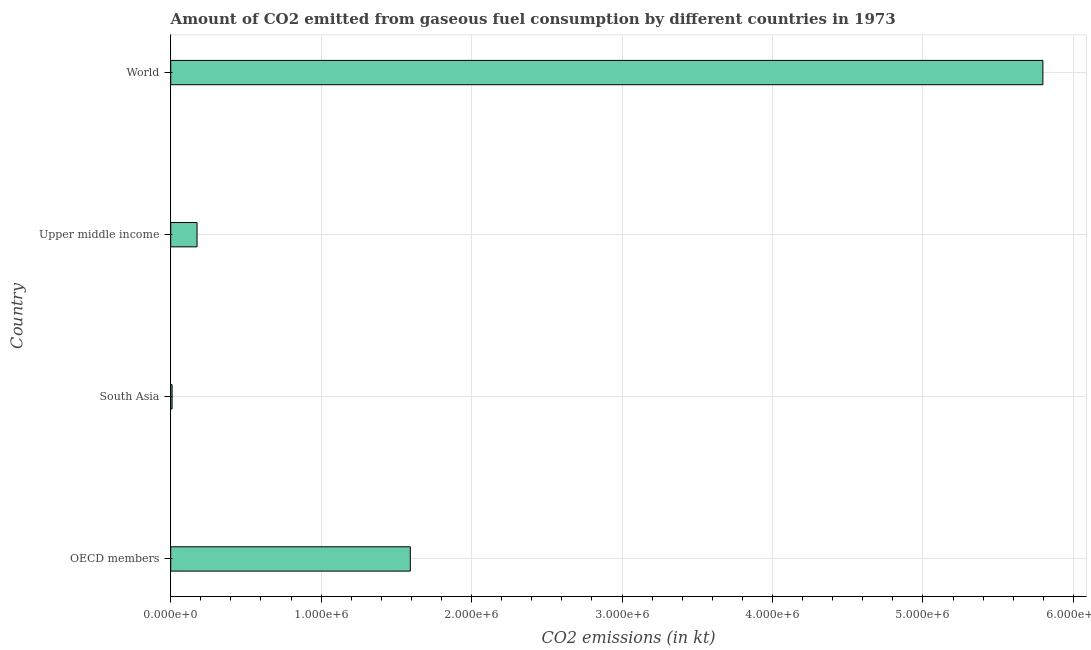Does the graph contain any zero values?
Make the answer very short. No. Does the graph contain grids?
Your response must be concise. Yes. What is the title of the graph?
Provide a short and direct response. Amount of CO2 emitted from gaseous fuel consumption by different countries in 1973. What is the label or title of the X-axis?
Give a very brief answer. CO2 emissions (in kt). What is the co2 emissions from gaseous fuel consumption in OECD members?
Provide a succinct answer. 1.59e+06. Across all countries, what is the maximum co2 emissions from gaseous fuel consumption?
Keep it short and to the point. 5.80e+06. Across all countries, what is the minimum co2 emissions from gaseous fuel consumption?
Ensure brevity in your answer.  9117.53. What is the sum of the co2 emissions from gaseous fuel consumption?
Make the answer very short. 7.57e+06. What is the difference between the co2 emissions from gaseous fuel consumption in South Asia and World?
Make the answer very short. -5.79e+06. What is the average co2 emissions from gaseous fuel consumption per country?
Your response must be concise. 1.89e+06. What is the median co2 emissions from gaseous fuel consumption?
Your response must be concise. 8.84e+05. What is the ratio of the co2 emissions from gaseous fuel consumption in OECD members to that in World?
Offer a very short reply. 0.28. Is the difference between the co2 emissions from gaseous fuel consumption in OECD members and World greater than the difference between any two countries?
Offer a terse response. No. What is the difference between the highest and the second highest co2 emissions from gaseous fuel consumption?
Keep it short and to the point. 4.20e+06. What is the difference between the highest and the lowest co2 emissions from gaseous fuel consumption?
Your answer should be compact. 5.79e+06. In how many countries, is the co2 emissions from gaseous fuel consumption greater than the average co2 emissions from gaseous fuel consumption taken over all countries?
Keep it short and to the point. 1. How many bars are there?
Keep it short and to the point. 4. Are all the bars in the graph horizontal?
Offer a terse response. Yes. What is the difference between two consecutive major ticks on the X-axis?
Give a very brief answer. 1.00e+06. What is the CO2 emissions (in kt) in OECD members?
Provide a short and direct response. 1.59e+06. What is the CO2 emissions (in kt) of South Asia?
Give a very brief answer. 9117.53. What is the CO2 emissions (in kt) in Upper middle income?
Offer a terse response. 1.75e+05. What is the CO2 emissions (in kt) of World?
Your answer should be compact. 5.80e+06. What is the difference between the CO2 emissions (in kt) in OECD members and South Asia?
Give a very brief answer. 1.58e+06. What is the difference between the CO2 emissions (in kt) in OECD members and Upper middle income?
Provide a succinct answer. 1.42e+06. What is the difference between the CO2 emissions (in kt) in OECD members and World?
Provide a succinct answer. -4.20e+06. What is the difference between the CO2 emissions (in kt) in South Asia and Upper middle income?
Keep it short and to the point. -1.66e+05. What is the difference between the CO2 emissions (in kt) in South Asia and World?
Provide a succinct answer. -5.79e+06. What is the difference between the CO2 emissions (in kt) in Upper middle income and World?
Ensure brevity in your answer.  -5.62e+06. What is the ratio of the CO2 emissions (in kt) in OECD members to that in South Asia?
Your answer should be compact. 174.68. What is the ratio of the CO2 emissions (in kt) in OECD members to that in Upper middle income?
Your response must be concise. 9.1. What is the ratio of the CO2 emissions (in kt) in OECD members to that in World?
Your answer should be very brief. 0.28. What is the ratio of the CO2 emissions (in kt) in South Asia to that in Upper middle income?
Provide a succinct answer. 0.05. What is the ratio of the CO2 emissions (in kt) in South Asia to that in World?
Give a very brief answer. 0. 